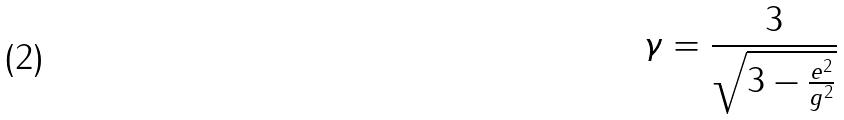<formula> <loc_0><loc_0><loc_500><loc_500>\gamma = \frac { 3 } { \sqrt { 3 - \frac { e ^ { 2 } } { g ^ { 2 } } } }</formula> 